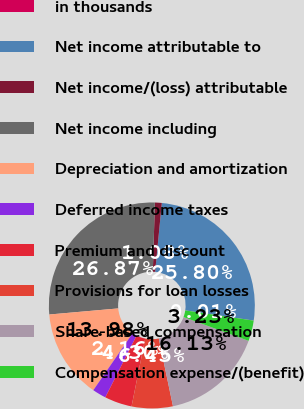<chart> <loc_0><loc_0><loc_500><loc_500><pie_chart><fcel>in thousands<fcel>Net income attributable to<fcel>Net income/(loss) attributable<fcel>Net income including<fcel>Depreciation and amortization<fcel>Deferred income taxes<fcel>Premium and discount<fcel>Provisions for loan losses<fcel>Share-based compensation<fcel>Compensation expense/(benefit)<nl><fcel>0.01%<fcel>25.8%<fcel>1.08%<fcel>26.87%<fcel>13.98%<fcel>2.16%<fcel>4.3%<fcel>6.45%<fcel>16.13%<fcel>3.23%<nl></chart> 